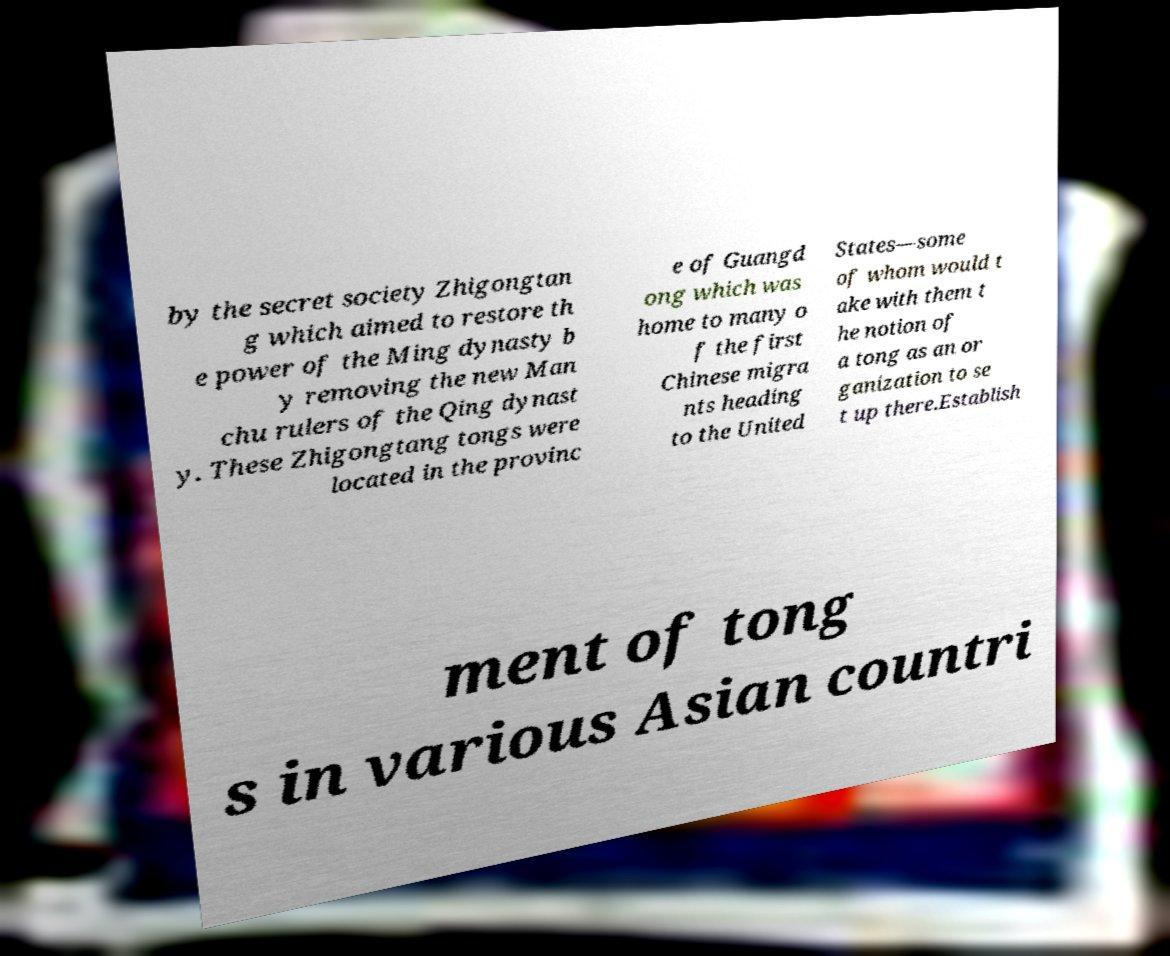Please read and relay the text visible in this image. What does it say? by the secret society Zhigongtan g which aimed to restore th e power of the Ming dynasty b y removing the new Man chu rulers of the Qing dynast y. These Zhigongtang tongs were located in the provinc e of Guangd ong which was home to many o f the first Chinese migra nts heading to the United States—some of whom would t ake with them t he notion of a tong as an or ganization to se t up there.Establish ment of tong s in various Asian countri 